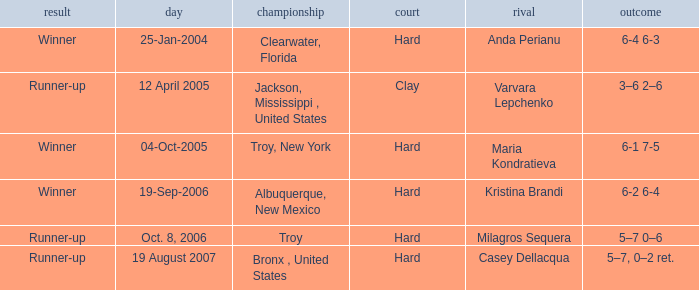What was the outcome of the game played on 19-Sep-2006? Winner. 